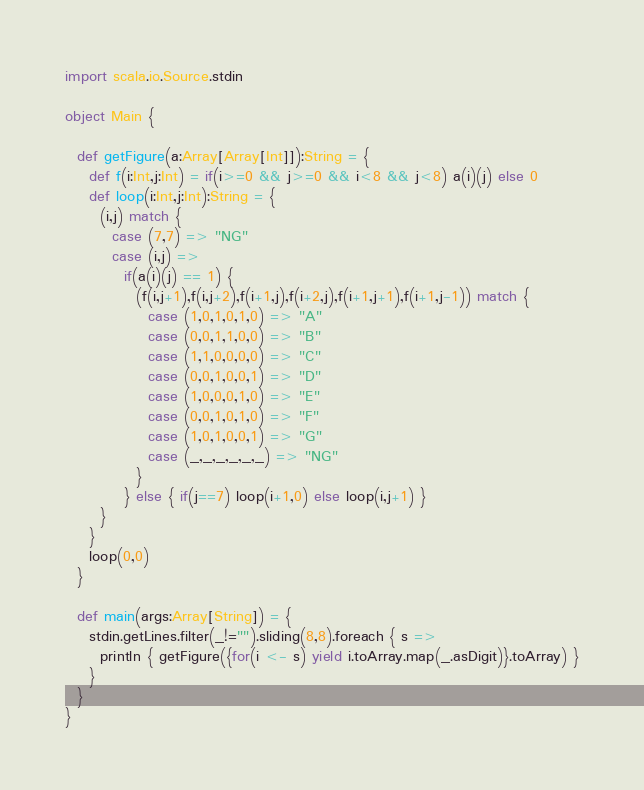Convert code to text. <code><loc_0><loc_0><loc_500><loc_500><_Scala_>import scala.io.Source.stdin

object Main {

  def getFigure(a:Array[Array[Int]]):String = {
    def f(i:Int,j:Int) = if(i>=0 && j>=0 && i<8 && j<8) a(i)(j) else 0
    def loop(i:Int,j:Int):String = {
      (i,j) match {
        case (7,7) => "NG"
        case (i,j) =>
          if(a(i)(j) == 1) {
            (f(i,j+1),f(i,j+2),f(i+1,j),f(i+2,j),f(i+1,j+1),f(i+1,j-1)) match {
              case (1,0,1,0,1,0) => "A"
              case (0,0,1,1,0,0) => "B"
              case (1,1,0,0,0,0) => "C"
              case (0,0,1,0,0,1) => "D"
              case (1,0,0,0,1,0) => "E"
              case (0,0,1,0,1,0) => "F"
              case (1,0,1,0,0,1) => "G"
              case (_,_,_,_,_,_) => "NG"
            }
          } else { if(j==7) loop(i+1,0) else loop(i,j+1) }
      }
    }
    loop(0,0)
  }

  def main(args:Array[String]) = {
    stdin.getLines.filter(_!="").sliding(8,8).foreach { s =>
      println { getFigure({for(i <- s) yield i.toArray.map(_.asDigit)}.toArray) }
    }
  }
}</code> 